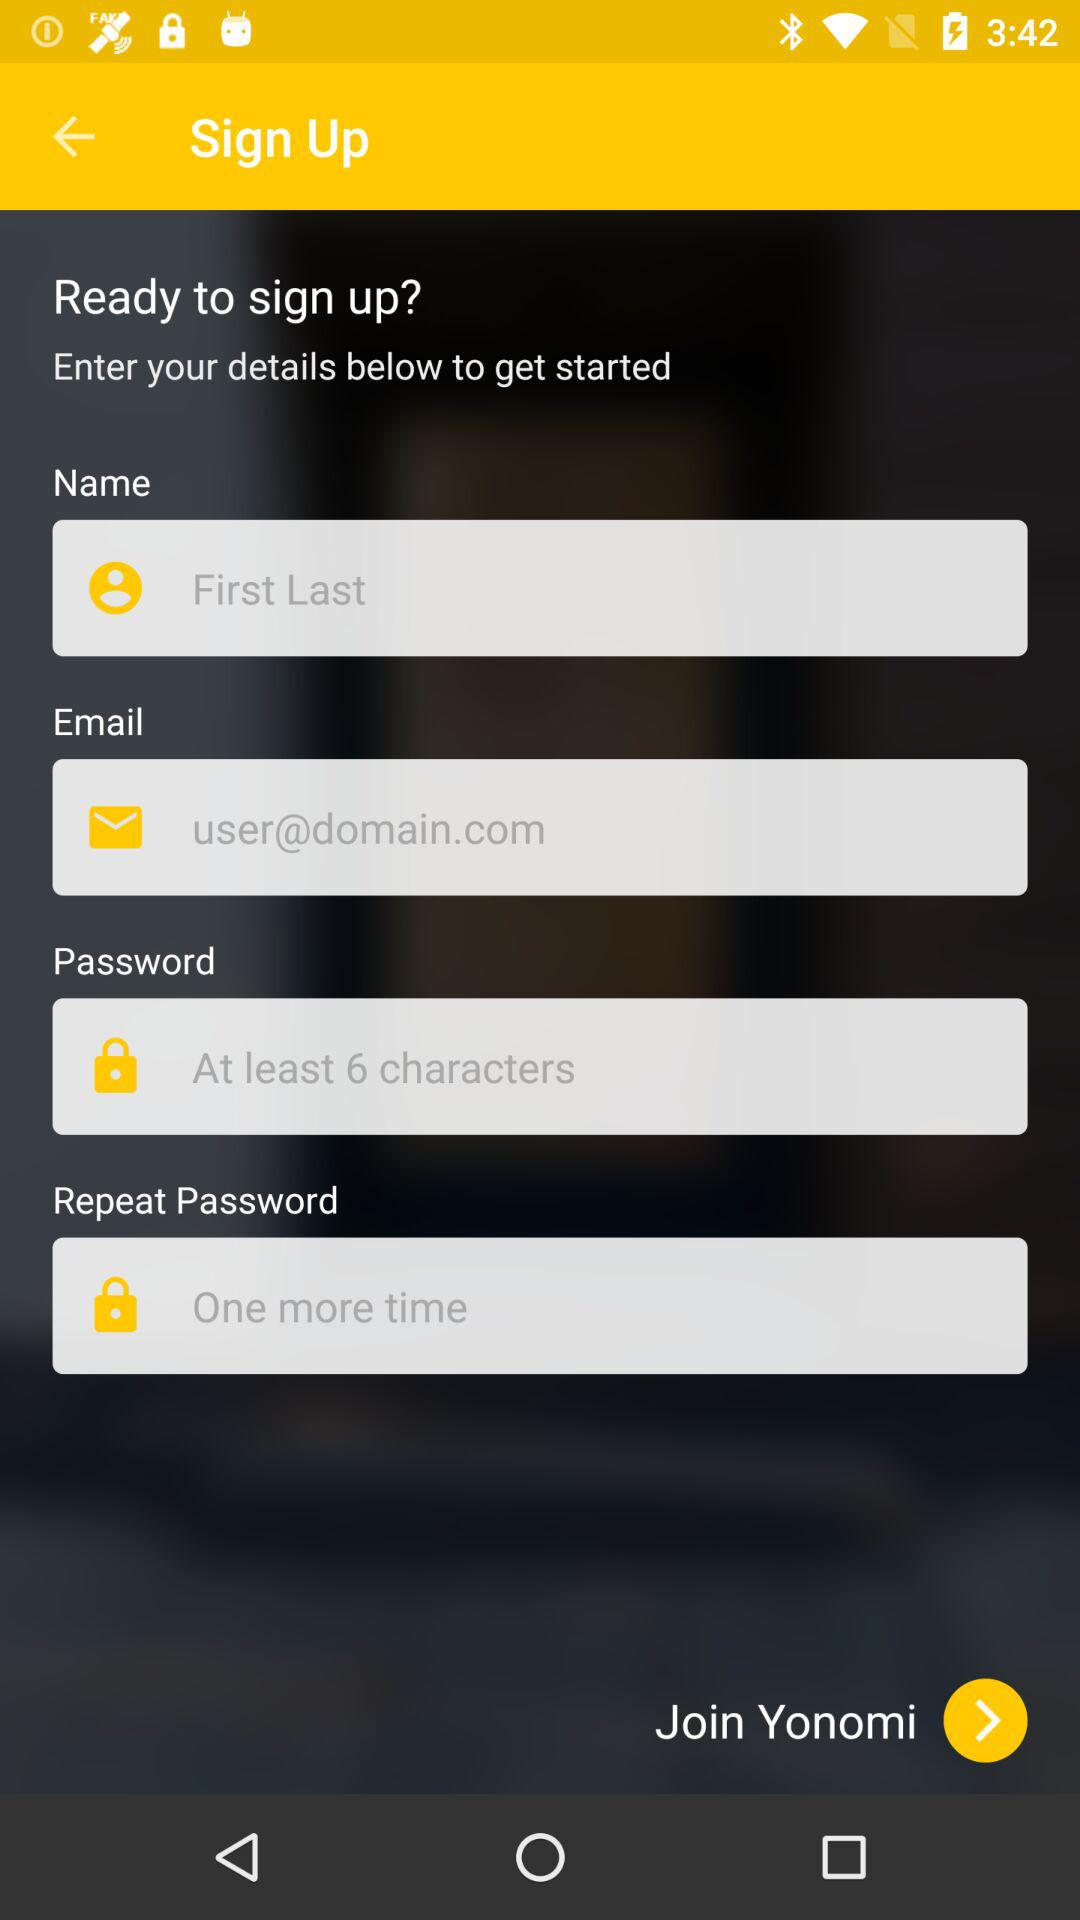What's the name?
When the provided information is insufficient, respond with <no answer>. <no answer> 